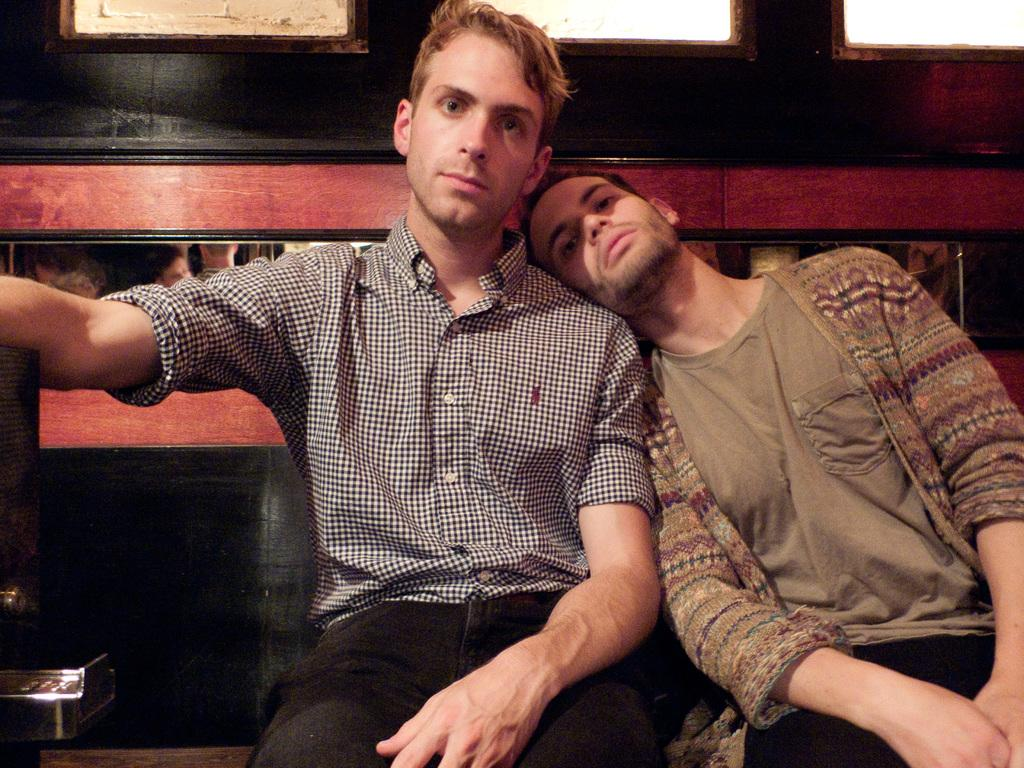How many people are in the image? There are two people in the image. What are the people doing in the image? The two people are sitting on a bench. What can be seen behind the people in the image? There is a wall behind the people. What type of jellyfish can be seen swimming near the people in the image? There are no jellyfish present in the image; it features two people sitting on a bench with a wall behind them. 